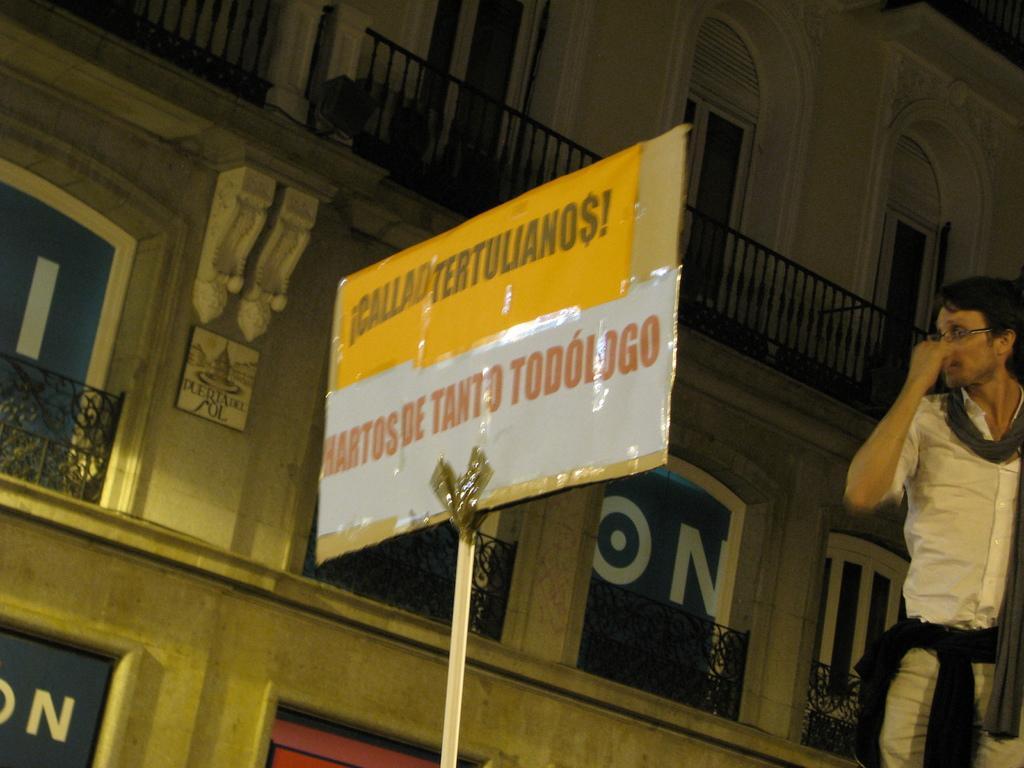How would you summarize this image in a sentence or two? This image consists of a building and a placard. To the right, there is a man wearing a white dress. In the background, there are railing and doors along with windows to the building. 